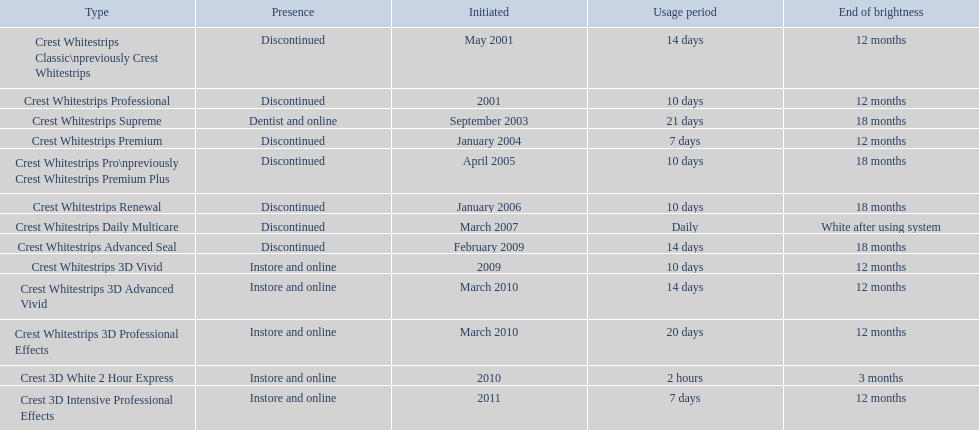How many models require less than a week of use? 2. Could you parse the entire table as a dict? {'header': ['Type', 'Presence', 'Initiated', 'Usage period', 'End of brightness'], 'rows': [['Crest Whitestrips Classic\\npreviously Crest Whitestrips', 'Discontinued', 'May 2001', '14 days', '12 months'], ['Crest Whitestrips Professional', 'Discontinued', '2001', '10 days', '12 months'], ['Crest Whitestrips Supreme', 'Dentist and online', 'September 2003', '21 days', '18 months'], ['Crest Whitestrips Premium', 'Discontinued', 'January 2004', '7 days', '12 months'], ['Crest Whitestrips Pro\\npreviously Crest Whitestrips Premium Plus', 'Discontinued', 'April 2005', '10 days', '18 months'], ['Crest Whitestrips Renewal', 'Discontinued', 'January 2006', '10 days', '18 months'], ['Crest Whitestrips Daily Multicare', 'Discontinued', 'March 2007', 'Daily', 'White after using system'], ['Crest Whitestrips Advanced Seal', 'Discontinued', 'February 2009', '14 days', '18 months'], ['Crest Whitestrips 3D Vivid', 'Instore and online', '2009', '10 days', '12 months'], ['Crest Whitestrips 3D Advanced Vivid', 'Instore and online', 'March 2010', '14 days', '12 months'], ['Crest Whitestrips 3D Professional Effects', 'Instore and online', 'March 2010', '20 days', '12 months'], ['Crest 3D White 2 Hour Express', 'Instore and online', '2010', '2 hours', '3 months'], ['Crest 3D Intensive Professional Effects', 'Instore and online', '2011', '7 days', '12 months']]} 